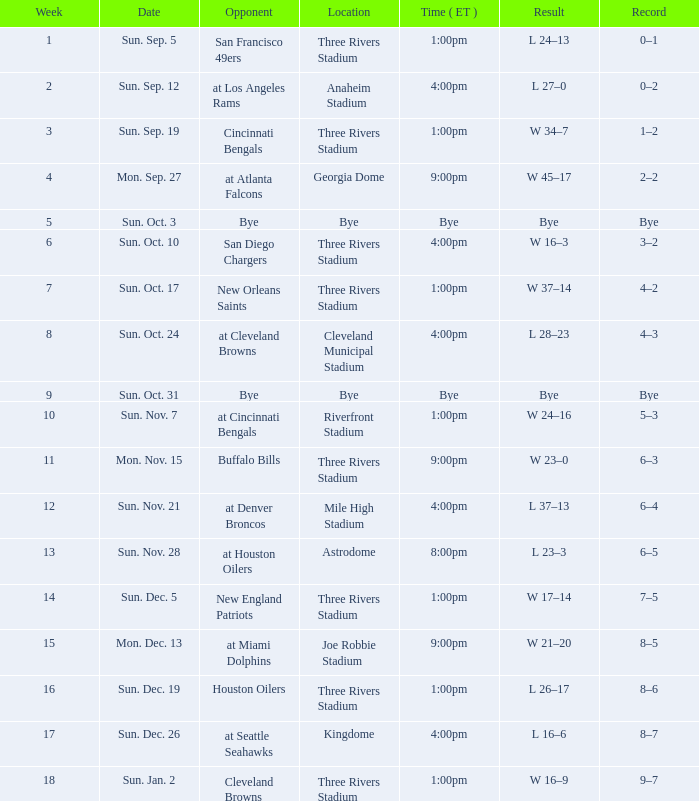What is the game's record with a final score of 45-17 in favor of team w? 2–2. 